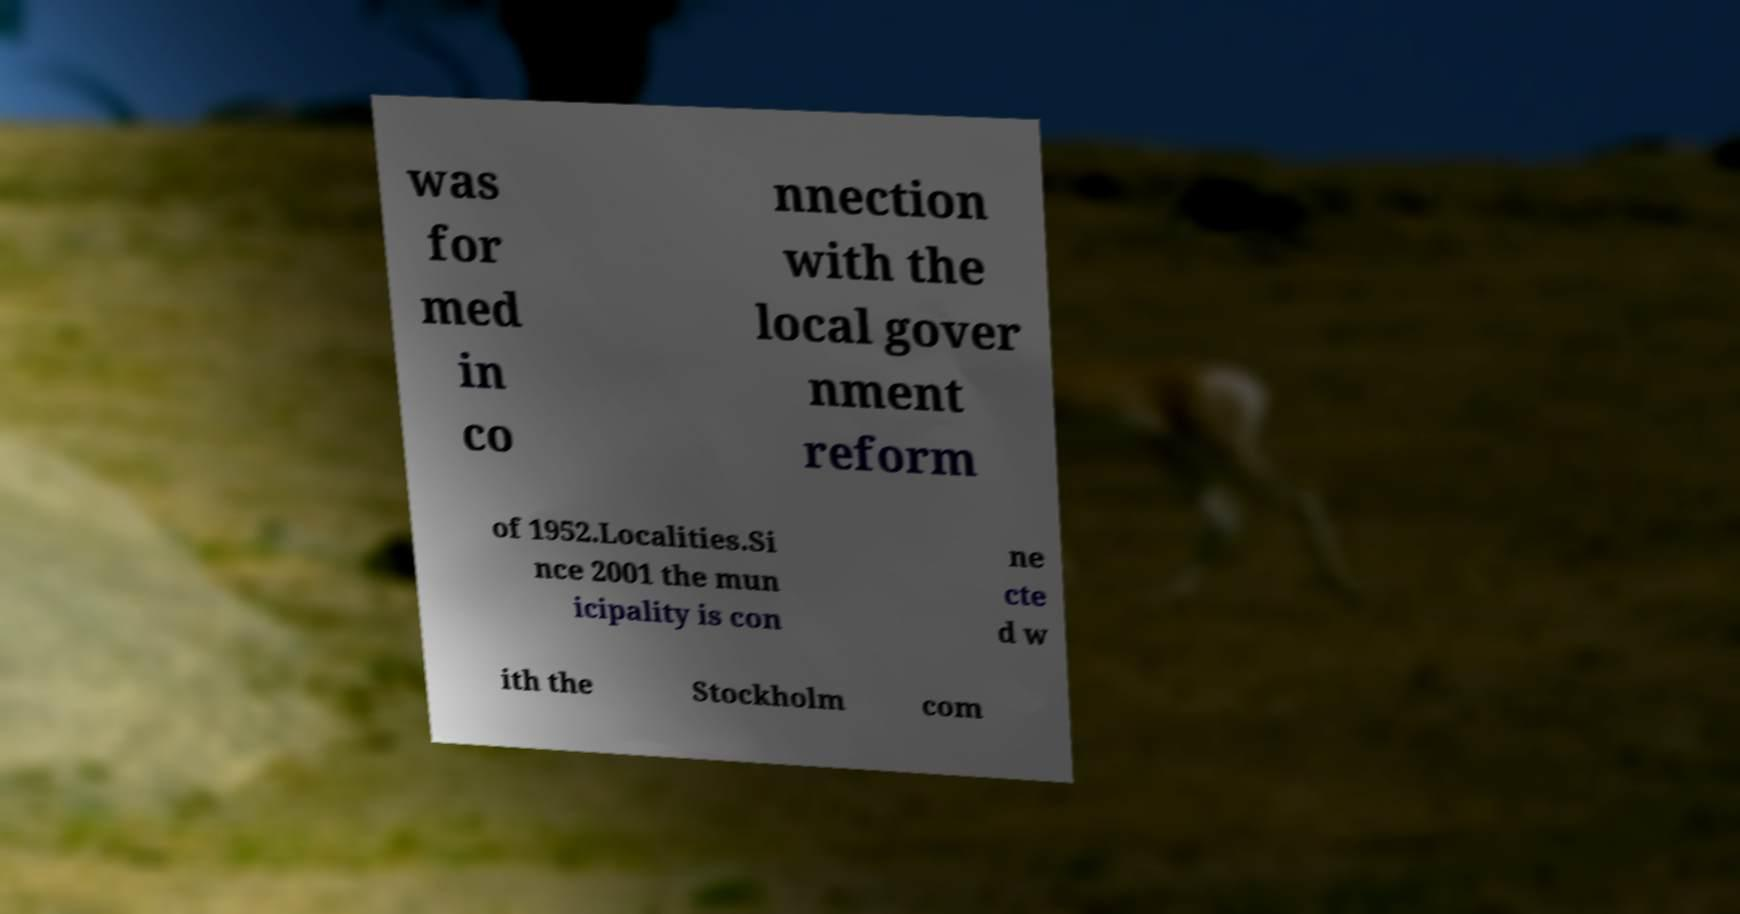Can you read and provide the text displayed in the image?This photo seems to have some interesting text. Can you extract and type it out for me? was for med in co nnection with the local gover nment reform of 1952.Localities.Si nce 2001 the mun icipality is con ne cte d w ith the Stockholm com 